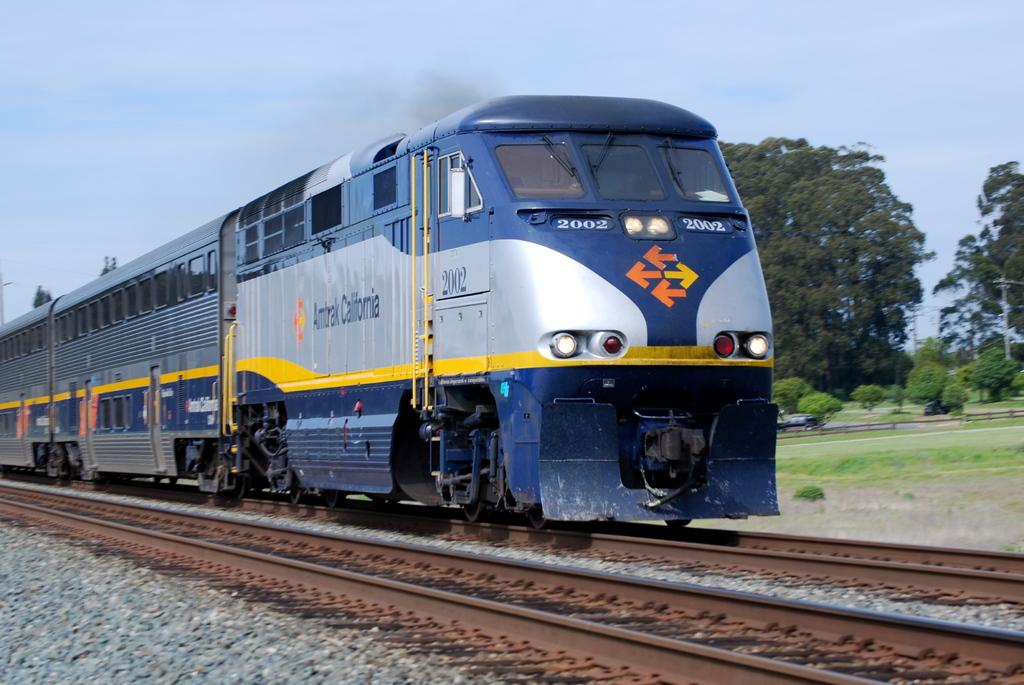What can be seen running along the ground in the image? There are train tracks in the image, and a train is moving on the tracks. What is visible in the background of the image? There are trees and the sky visible in the background of the image. Can you describe the kitten's haircut in the image? There is no kitten or haircut present in the image. What type of van is parked near the train tracks in the image? There is no van present in the image; it only features train tracks and a moving train. 